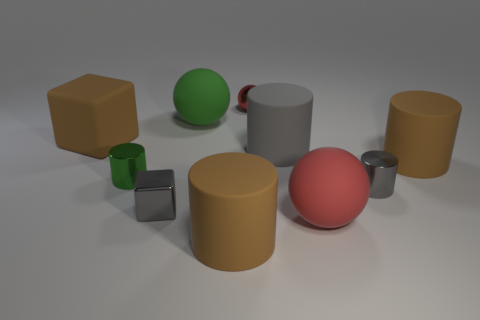What shape is the large rubber thing that is the same color as the tiny metallic ball?
Keep it short and to the point. Sphere. Are there any other things that are the same color as the shiny cube?
Your answer should be very brief. Yes. How many rubber spheres are the same color as the shiny ball?
Your answer should be very brief. 1. There is a large rubber sphere behind the large cube; is its color the same as the tiny metallic cylinder that is left of the small red thing?
Your answer should be very brief. Yes. What is the size of the metallic cylinder that is the same color as the small metal cube?
Provide a succinct answer. Small. What is the shape of the green rubber thing?
Your answer should be very brief. Sphere. There is a small cylinder that is right of the green shiny cylinder; is its color the same as the shiny block?
Provide a succinct answer. Yes. There is a red matte thing that is the same shape as the large green matte object; what size is it?
Your response must be concise. Large. Are there any green rubber objects on the left side of the big brown thing in front of the matte sphere in front of the small green thing?
Make the answer very short. Yes. What material is the block that is right of the large brown matte cube?
Make the answer very short. Metal. 